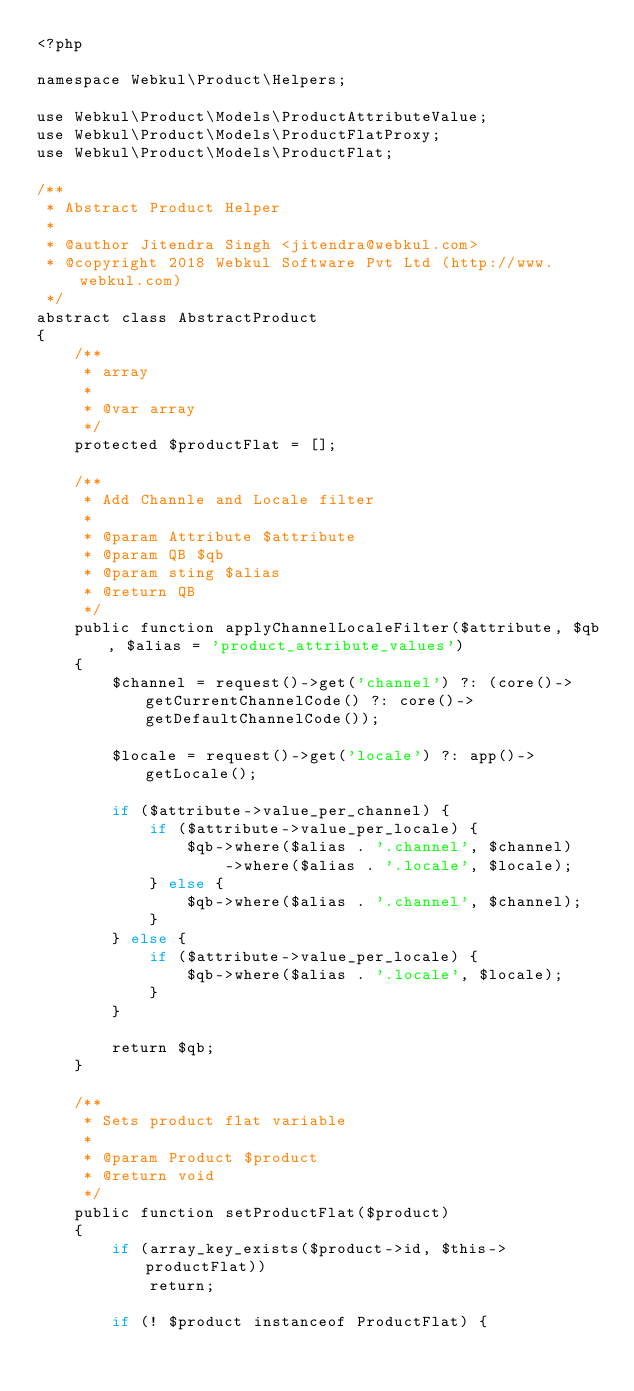Convert code to text. <code><loc_0><loc_0><loc_500><loc_500><_PHP_><?php

namespace Webkul\Product\Helpers;

use Webkul\Product\Models\ProductAttributeValue;
use Webkul\Product\Models\ProductFlatProxy;
use Webkul\Product\Models\ProductFlat;

/**
 * Abstract Product Helper
 *
 * @author Jitendra Singh <jitendra@webkul.com>
 * @copyright 2018 Webkul Software Pvt Ltd (http://www.webkul.com)
 */
abstract class AbstractProduct
{
    /**
     * array
     *
     * @var array
     */
    protected $productFlat = [];

    /**
     * Add Channle and Locale filter
     *
     * @param Attribute $attribute
     * @param QB $qb
     * @param sting $alias
     * @return QB
     */
    public function applyChannelLocaleFilter($attribute, $qb, $alias = 'product_attribute_values')
    {
        $channel = request()->get('channel') ?: (core()->getCurrentChannelCode() ?: core()->getDefaultChannelCode());

        $locale = request()->get('locale') ?: app()->getLocale();

        if ($attribute->value_per_channel) {
            if ($attribute->value_per_locale) {
                $qb->where($alias . '.channel', $channel)
                    ->where($alias . '.locale', $locale);
            } else {
                $qb->where($alias . '.channel', $channel);
            }
        } else {
            if ($attribute->value_per_locale) {
                $qb->where($alias . '.locale', $locale);
            }
        }

        return $qb;
    }

    /**
     * Sets product flat variable
     *
     * @param Product $product
     * @return void
     */
    public function setProductFlat($product)
    {
        if (array_key_exists($product->id, $this->productFlat))
            return;

        if (! $product instanceof ProductFlat) {</code> 